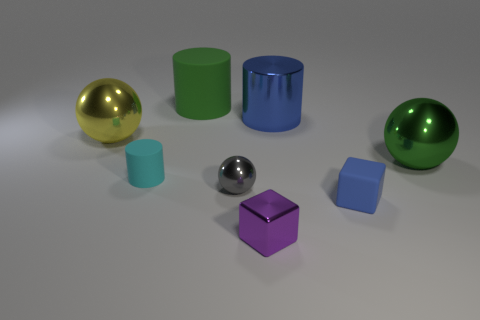Subtract all big cylinders. How many cylinders are left? 1 Add 2 tiny green blocks. How many objects exist? 10 Subtract 1 cubes. How many cubes are left? 1 Subtract all green cylinders. How many cylinders are left? 2 Subtract 0 brown cubes. How many objects are left? 8 Subtract all cubes. How many objects are left? 6 Subtract all purple balls. Subtract all red cylinders. How many balls are left? 3 Subtract all green balls. How many cyan cylinders are left? 1 Subtract all cyan matte cylinders. Subtract all blue objects. How many objects are left? 5 Add 1 tiny gray objects. How many tiny gray objects are left? 2 